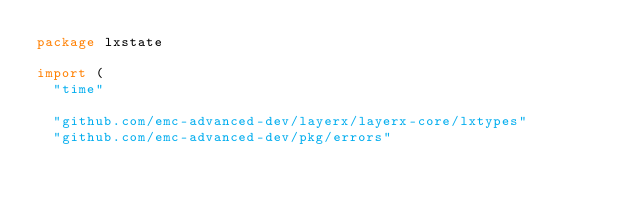Convert code to text. <code><loc_0><loc_0><loc_500><loc_500><_Go_>package lxstate

import (
	"time"

	"github.com/emc-advanced-dev/layerx/layerx-core/lxtypes"
	"github.com/emc-advanced-dev/pkg/errors"</code> 